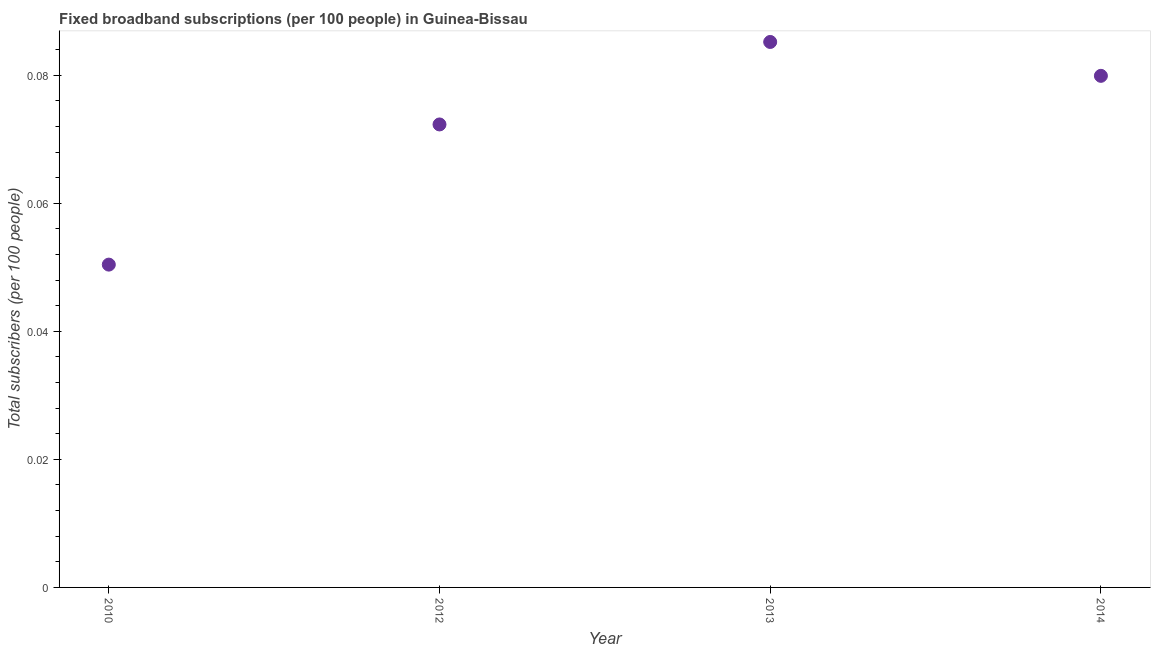What is the total number of fixed broadband subscriptions in 2010?
Provide a succinct answer. 0.05. Across all years, what is the maximum total number of fixed broadband subscriptions?
Provide a short and direct response. 0.09. Across all years, what is the minimum total number of fixed broadband subscriptions?
Offer a terse response. 0.05. In which year was the total number of fixed broadband subscriptions maximum?
Offer a terse response. 2013. What is the sum of the total number of fixed broadband subscriptions?
Provide a short and direct response. 0.29. What is the difference between the total number of fixed broadband subscriptions in 2012 and 2013?
Give a very brief answer. -0.01. What is the average total number of fixed broadband subscriptions per year?
Make the answer very short. 0.07. What is the median total number of fixed broadband subscriptions?
Provide a succinct answer. 0.08. What is the ratio of the total number of fixed broadband subscriptions in 2010 to that in 2012?
Provide a short and direct response. 0.7. Is the difference between the total number of fixed broadband subscriptions in 2012 and 2013 greater than the difference between any two years?
Your response must be concise. No. What is the difference between the highest and the second highest total number of fixed broadband subscriptions?
Offer a very short reply. 0.01. What is the difference between the highest and the lowest total number of fixed broadband subscriptions?
Ensure brevity in your answer.  0.03. How many dotlines are there?
Ensure brevity in your answer.  1. How many years are there in the graph?
Provide a succinct answer. 4. What is the difference between two consecutive major ticks on the Y-axis?
Your answer should be compact. 0.02. Does the graph contain any zero values?
Give a very brief answer. No. What is the title of the graph?
Provide a short and direct response. Fixed broadband subscriptions (per 100 people) in Guinea-Bissau. What is the label or title of the X-axis?
Your answer should be compact. Year. What is the label or title of the Y-axis?
Provide a short and direct response. Total subscribers (per 100 people). What is the Total subscribers (per 100 people) in 2010?
Your answer should be compact. 0.05. What is the Total subscribers (per 100 people) in 2012?
Keep it short and to the point. 0.07. What is the Total subscribers (per 100 people) in 2013?
Your answer should be compact. 0.09. What is the Total subscribers (per 100 people) in 2014?
Keep it short and to the point. 0.08. What is the difference between the Total subscribers (per 100 people) in 2010 and 2012?
Ensure brevity in your answer.  -0.02. What is the difference between the Total subscribers (per 100 people) in 2010 and 2013?
Your answer should be compact. -0.03. What is the difference between the Total subscribers (per 100 people) in 2010 and 2014?
Your answer should be compact. -0.03. What is the difference between the Total subscribers (per 100 people) in 2012 and 2013?
Make the answer very short. -0.01. What is the difference between the Total subscribers (per 100 people) in 2012 and 2014?
Give a very brief answer. -0.01. What is the difference between the Total subscribers (per 100 people) in 2013 and 2014?
Give a very brief answer. 0.01. What is the ratio of the Total subscribers (per 100 people) in 2010 to that in 2012?
Keep it short and to the point. 0.7. What is the ratio of the Total subscribers (per 100 people) in 2010 to that in 2013?
Your answer should be very brief. 0.59. What is the ratio of the Total subscribers (per 100 people) in 2010 to that in 2014?
Provide a short and direct response. 0.63. What is the ratio of the Total subscribers (per 100 people) in 2012 to that in 2013?
Your answer should be very brief. 0.85. What is the ratio of the Total subscribers (per 100 people) in 2012 to that in 2014?
Provide a short and direct response. 0.91. What is the ratio of the Total subscribers (per 100 people) in 2013 to that in 2014?
Provide a succinct answer. 1.07. 